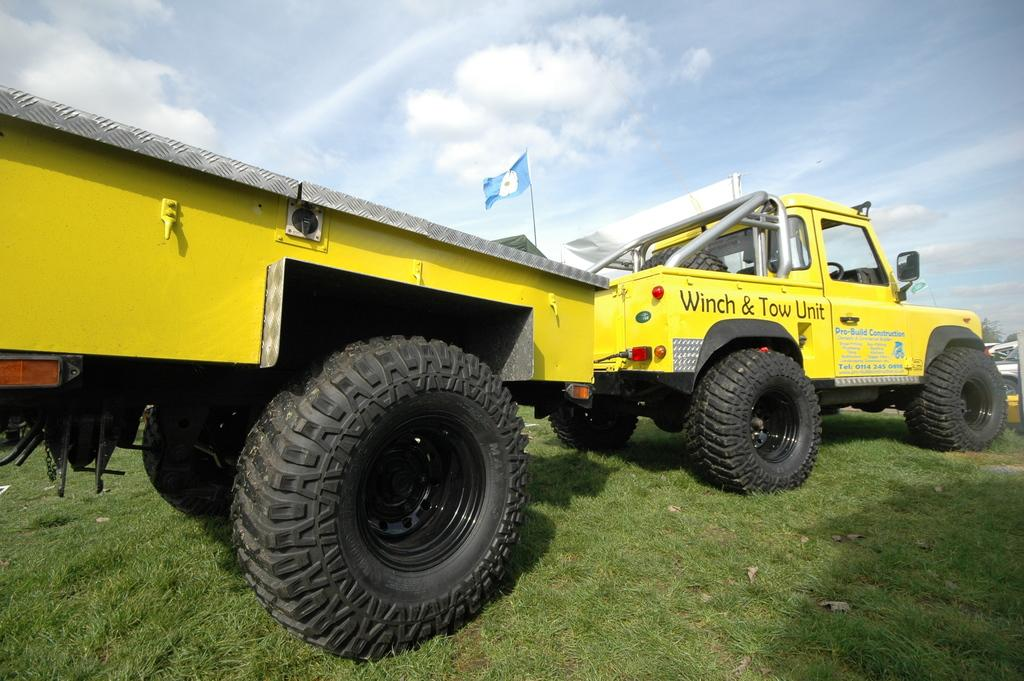What color is the truck in the image? The truck in the image is yellow. What other object can be seen in the image besides the truck? There is a black color wheel in the image. Where is the wheel located? The wheel is on the grass. What other colorful object is present in the image? There is a blue color flag in the image. What can be seen in the background of the image? The sky is visible in the image, and clouds are present in the sky. How does the truck tie a knot in the image? The truck does not tie a knot in the image; it is a vehicle and cannot perform such actions. 